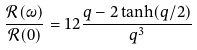Convert formula to latex. <formula><loc_0><loc_0><loc_500><loc_500>\frac { \mathcal { R } ( \omega ) } { \mathcal { R } ( 0 ) } = 1 2 \frac { q - 2 \tanh ( q / 2 ) } { q ^ { 3 } }</formula> 